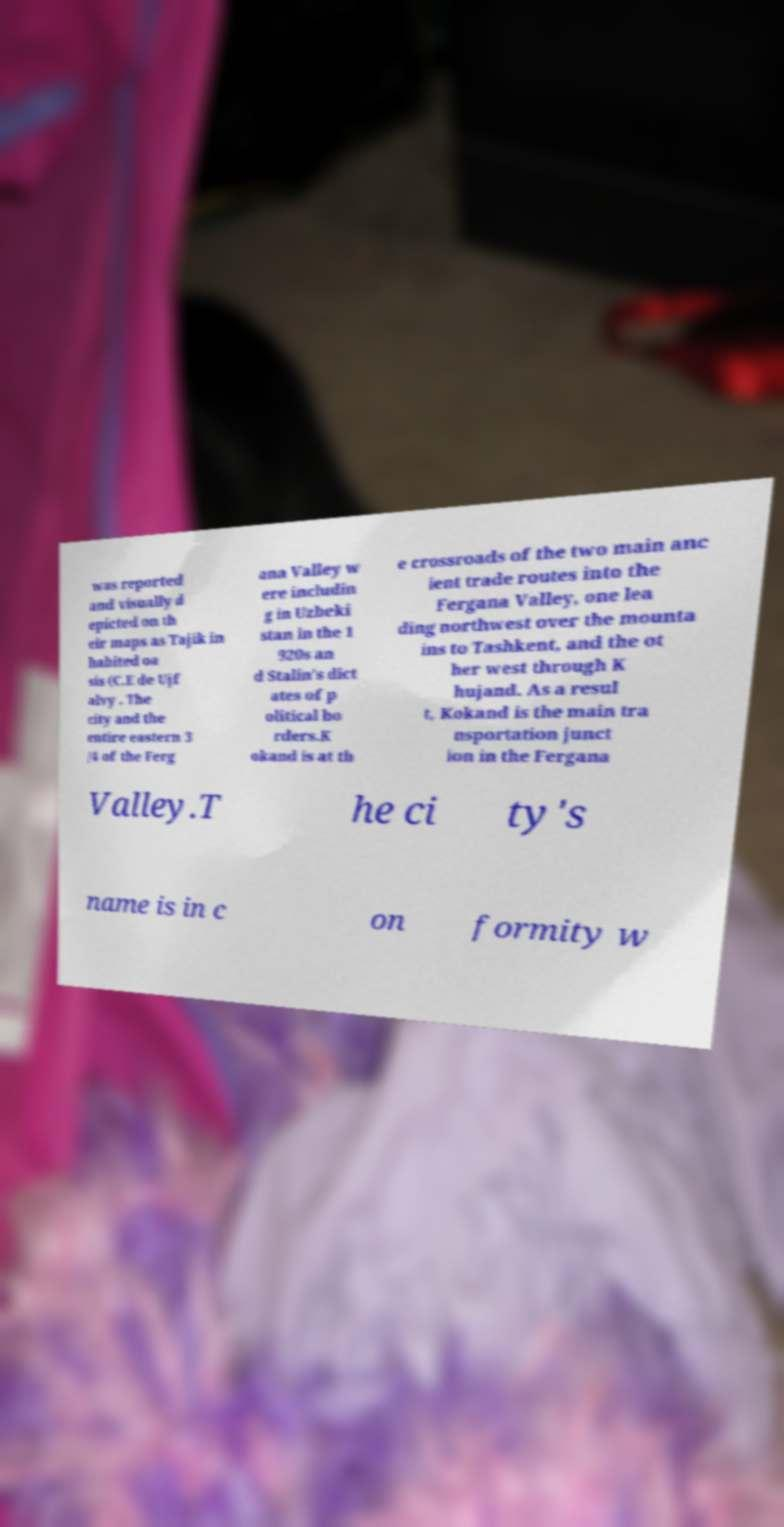Can you accurately transcribe the text from the provided image for me? was reported and visually d epicted on th eir maps as Tajik in habited oa sis (C.E de Ujf alvy . The city and the entire eastern 3 /4 of the Ferg ana Valley w ere includin g in Uzbeki stan in the 1 920s an d Stalin's dict ates of p olitical bo rders.K okand is at th e crossroads of the two main anc ient trade routes into the Fergana Valley, one lea ding northwest over the mounta ins to Tashkent, and the ot her west through K hujand. As a resul t, Kokand is the main tra nsportation junct ion in the Fergana Valley.T he ci ty's name is in c on formity w 